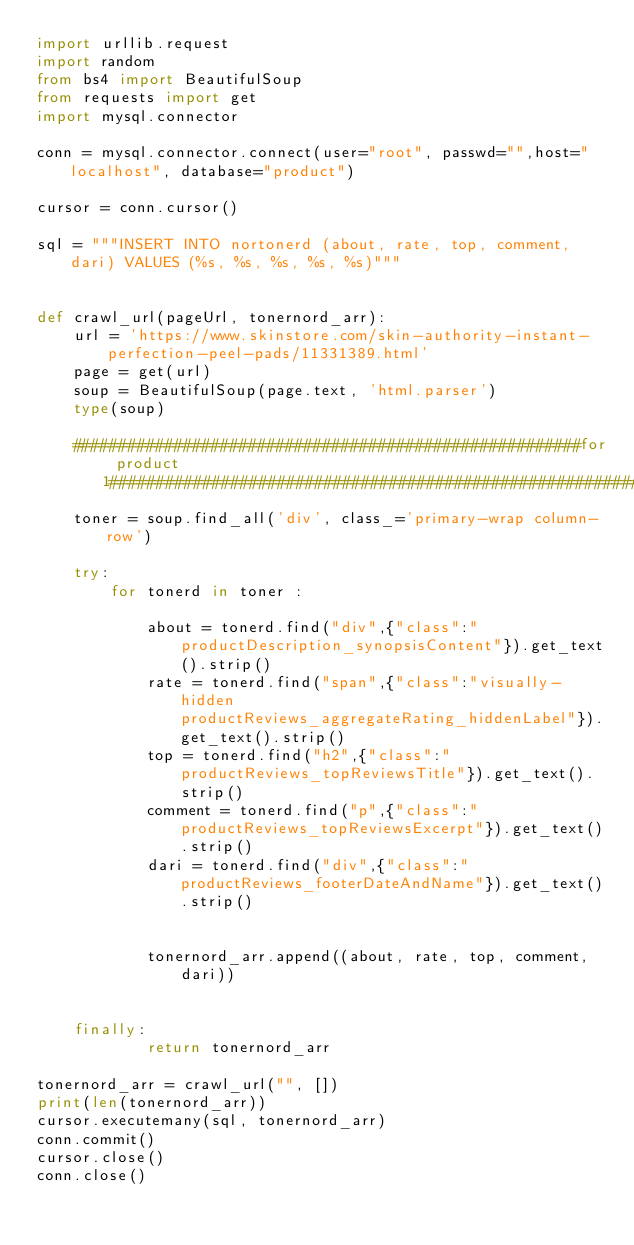Convert code to text. <code><loc_0><loc_0><loc_500><loc_500><_Python_>import urllib.request
import random
from bs4 import BeautifulSoup
from requests import get
import mysql.connector

conn = mysql.connector.connect(user="root", passwd="",host="localhost", database="product")

cursor = conn.cursor()

sql = """INSERT INTO nortonerd (about, rate, top, comment, dari) VALUES (%s, %s, %s, %s, %s)"""


def crawl_url(pageUrl, tonernord_arr):
    url = 'https://www.skinstore.com/skin-authority-instant-perfection-peel-pads/11331389.html'
    page = get(url)
    soup = BeautifulSoup(page.text, 'html.parser')
    type(soup)

    #######################################################for product 1############################################################################
    toner = soup.find_all('div', class_='primary-wrap column-row')

    try:
        for tonerd in toner :

            about = tonerd.find("div",{"class":"productDescription_synopsisContent"}).get_text().strip()
            rate = tonerd.find("span",{"class":"visually-hidden productReviews_aggregateRating_hiddenLabel"}).get_text().strip()
            top = tonerd.find("h2",{"class":"productReviews_topReviewsTitle"}).get_text().strip()
            comment = tonerd.find("p",{"class":"productReviews_topReviewsExcerpt"}).get_text().strip()
            dari = tonerd.find("div",{"class":"productReviews_footerDateAndName"}).get_text().strip()


            tonernord_arr.append((about, rate, top, comment, dari))


    finally:
            return tonernord_arr

tonernord_arr = crawl_url("", [])
print(len(tonernord_arr))
cursor.executemany(sql, tonernord_arr)
conn.commit()
cursor.close()
conn.close()
</code> 